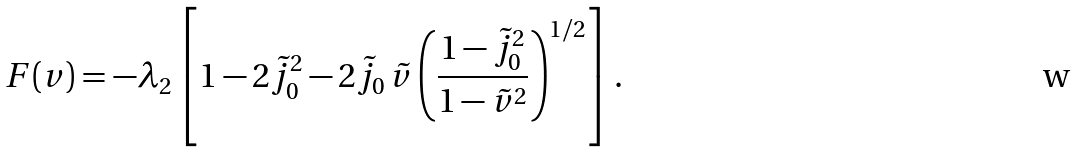Convert formula to latex. <formula><loc_0><loc_0><loc_500><loc_500>F ( v ) = - \lambda _ { 2 } \left [ 1 - 2 \tilde { j } _ { 0 } ^ { 2 } - 2 \tilde { j } _ { 0 } \, \tilde { v } \left ( \frac { 1 - \tilde { j } _ { 0 } ^ { 2 } } { 1 - \tilde { v } ^ { 2 } } \right ) ^ { 1 / 2 } \right ] .</formula> 